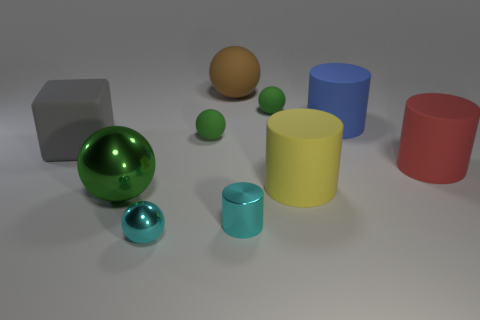Is there anything else that is the same size as the cube?
Your response must be concise. Yes. What is the shape of the large thing that is on the left side of the big sphere that is in front of the big cube that is to the left of the large blue matte object?
Offer a terse response. Cube. What number of other objects are there of the same color as the cube?
Your answer should be very brief. 0. The tiny matte thing that is on the left side of the rubber sphere to the right of the cyan cylinder is what shape?
Keep it short and to the point. Sphere. What number of big green shiny balls are in front of the big shiny object?
Your response must be concise. 0. Are there any big purple cylinders made of the same material as the big red cylinder?
Give a very brief answer. No. There is a yellow thing that is the same size as the blue rubber cylinder; what is it made of?
Your answer should be compact. Rubber. There is a object that is right of the small cyan cylinder and behind the blue cylinder; what size is it?
Give a very brief answer. Small. What is the color of the object that is both on the left side of the cyan sphere and in front of the large red thing?
Your response must be concise. Green. Is the number of tiny metal cylinders that are to the left of the brown rubber sphere less than the number of cyan objects that are behind the green shiny object?
Your answer should be compact. No. 